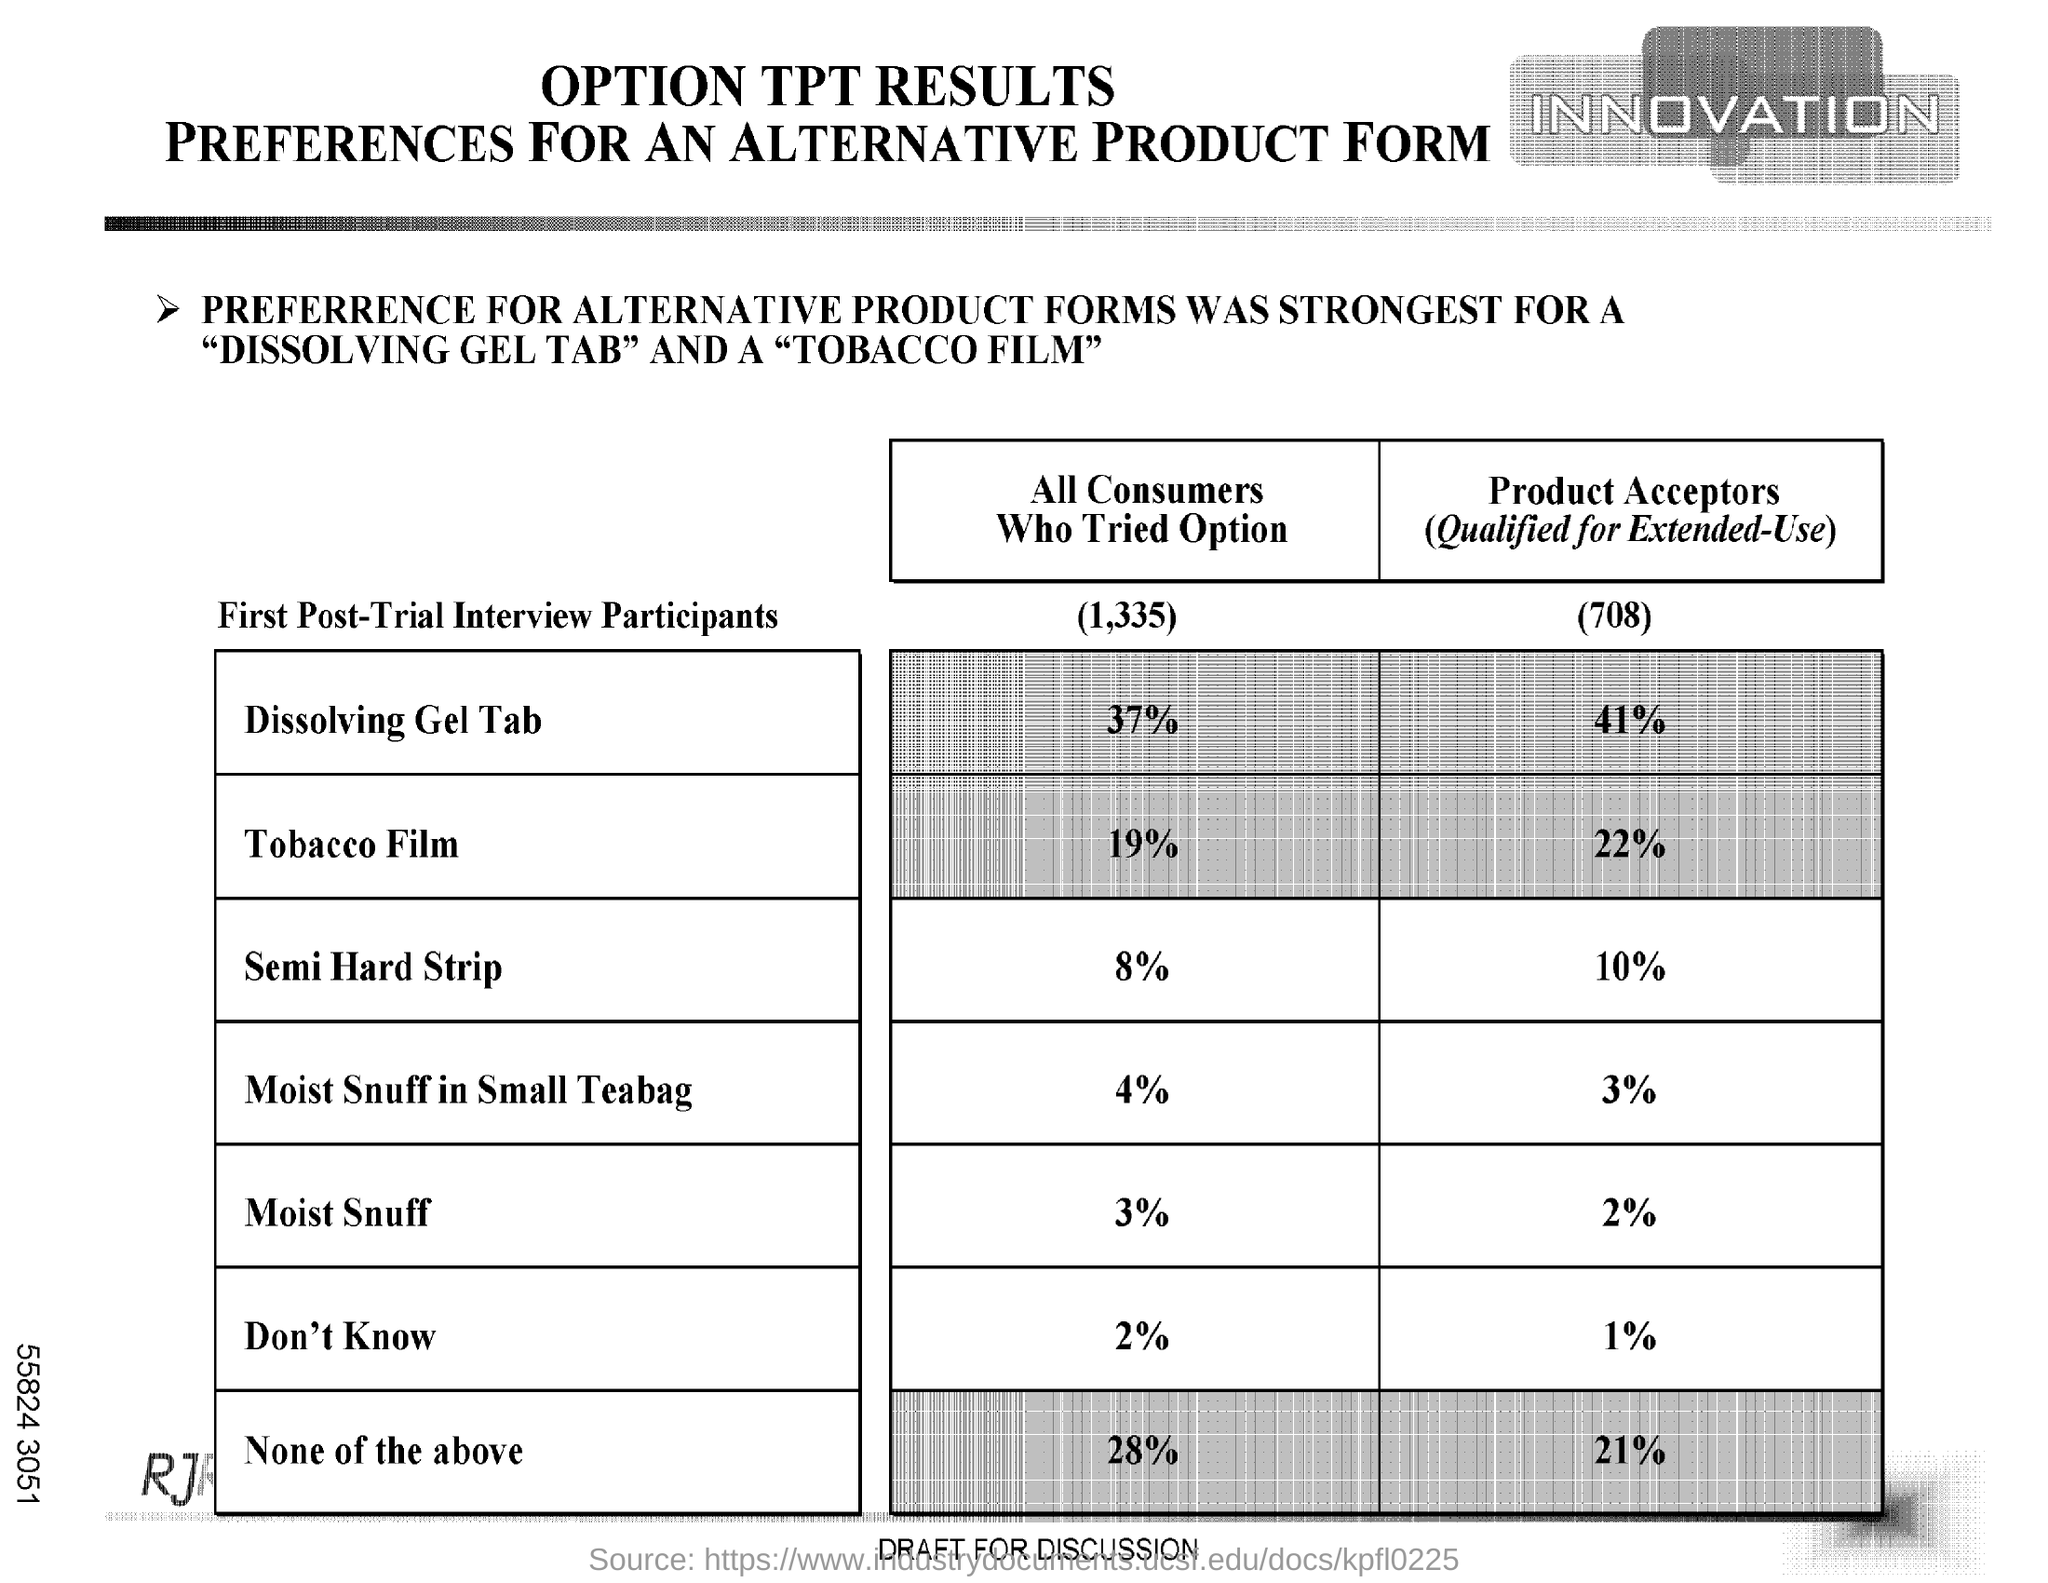What is the percentage of all consumers who tried option of "Semi Hard Strip"?
Offer a very short reply. 8. What is the percentage of all consumers who tried option of "Tobacco Film"?
Keep it short and to the point. 19. 